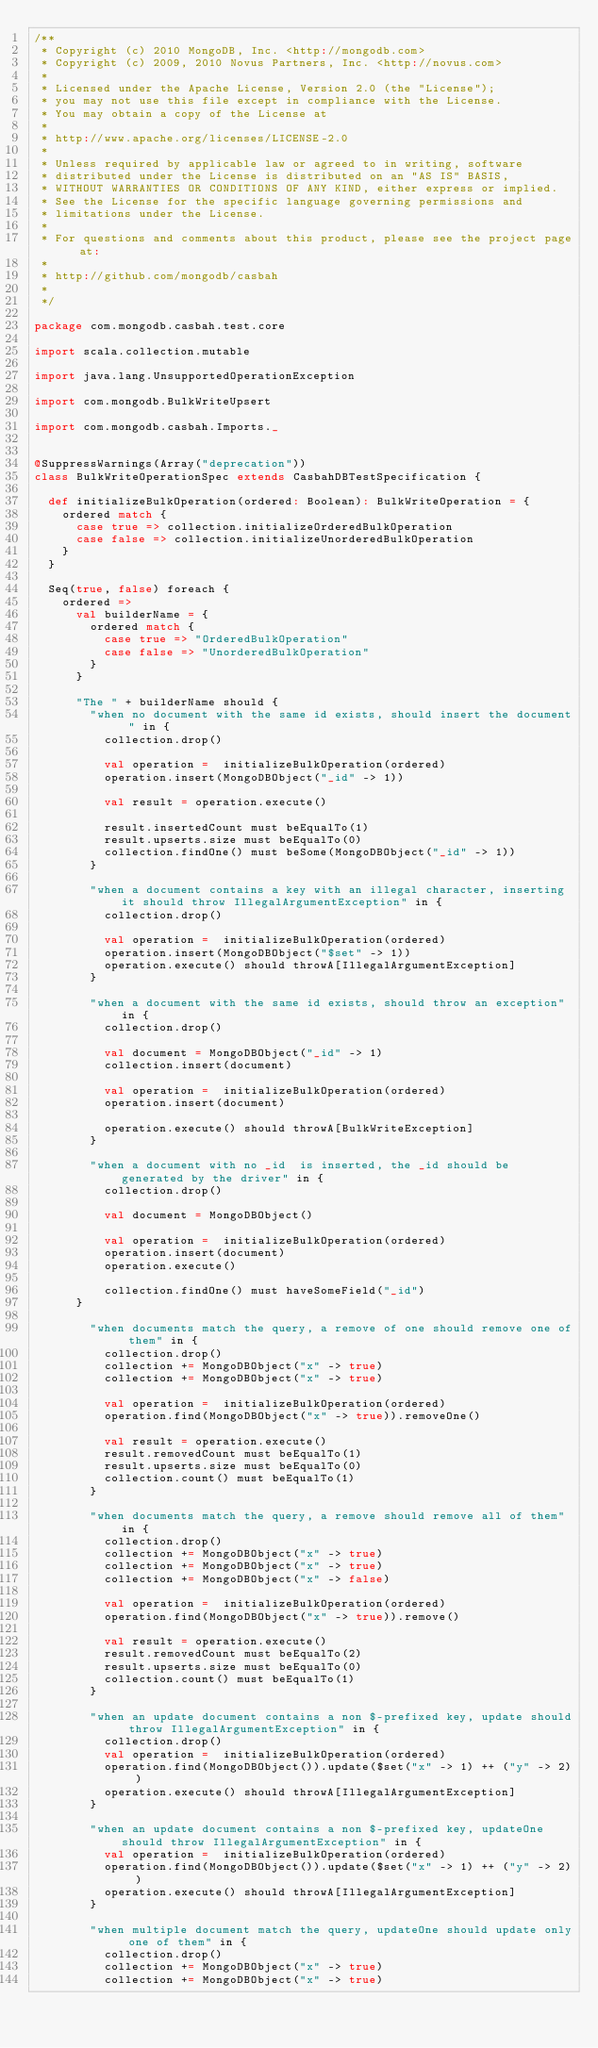<code> <loc_0><loc_0><loc_500><loc_500><_Scala_>/**
 * Copyright (c) 2010 MongoDB, Inc. <http://mongodb.com>
 * Copyright (c) 2009, 2010 Novus Partners, Inc. <http://novus.com>
 *
 * Licensed under the Apache License, Version 2.0 (the "License");
 * you may not use this file except in compliance with the License.
 * You may obtain a copy of the License at
 *
 * http://www.apache.org/licenses/LICENSE-2.0
 *
 * Unless required by applicable law or agreed to in writing, software
 * distributed under the License is distributed on an "AS IS" BASIS,
 * WITHOUT WARRANTIES OR CONDITIONS OF ANY KIND, either express or implied.
 * See the License for the specific language governing permissions and
 * limitations under the License.
 *
 * For questions and comments about this product, please see the project page at:
 *
 * http://github.com/mongodb/casbah
 *
 */

package com.mongodb.casbah.test.core

import scala.collection.mutable

import java.lang.UnsupportedOperationException

import com.mongodb.BulkWriteUpsert

import com.mongodb.casbah.Imports._


@SuppressWarnings(Array("deprecation"))
class BulkWriteOperationSpec extends CasbahDBTestSpecification {

  def initializeBulkOperation(ordered: Boolean): BulkWriteOperation = {
    ordered match {
      case true => collection.initializeOrderedBulkOperation
      case false => collection.initializeUnorderedBulkOperation
    }
  }

  Seq(true, false) foreach {
    ordered =>
      val builderName = {
        ordered match {
          case true => "OrderedBulkOperation"
          case false => "UnorderedBulkOperation"
        }
      }

      "The " + builderName should {
        "when no document with the same id exists, should insert the document " in {
          collection.drop()

          val operation =  initializeBulkOperation(ordered)
          operation.insert(MongoDBObject("_id" -> 1))

          val result = operation.execute()

          result.insertedCount must beEqualTo(1)
          result.upserts.size must beEqualTo(0)
          collection.findOne() must beSome(MongoDBObject("_id" -> 1))
        }

        "when a document contains a key with an illegal character, inserting it should throw IllegalArgumentException" in {
          collection.drop()

          val operation =  initializeBulkOperation(ordered)
          operation.insert(MongoDBObject("$set" -> 1))
          operation.execute() should throwA[IllegalArgumentException]
        }

        "when a document with the same id exists, should throw an exception" in {
          collection.drop()

          val document = MongoDBObject("_id" -> 1)
          collection.insert(document)

          val operation =  initializeBulkOperation(ordered)
          operation.insert(document)

          operation.execute() should throwA[BulkWriteException]
        }

        "when a document with no _id  is inserted, the _id should be generated by the driver" in {
          collection.drop()

          val document = MongoDBObject()

          val operation =  initializeBulkOperation(ordered)
          operation.insert(document)
          operation.execute()

          collection.findOne() must haveSomeField("_id")
      }

        "when documents match the query, a remove of one should remove one of them" in {
          collection.drop()
          collection += MongoDBObject("x" -> true)
          collection += MongoDBObject("x" -> true)

          val operation =  initializeBulkOperation(ordered)
          operation.find(MongoDBObject("x" -> true)).removeOne()

          val result = operation.execute()
          result.removedCount must beEqualTo(1)
          result.upserts.size must beEqualTo(0)
          collection.count() must beEqualTo(1)
        }

        "when documents match the query, a remove should remove all of them" in {
          collection.drop()
          collection += MongoDBObject("x" -> true)
          collection += MongoDBObject("x" -> true)
          collection += MongoDBObject("x" -> false)

          val operation =  initializeBulkOperation(ordered)
          operation.find(MongoDBObject("x" -> true)).remove()

          val result = operation.execute()
          result.removedCount must beEqualTo(2)
          result.upserts.size must beEqualTo(0)
          collection.count() must beEqualTo(1)
        }

        "when an update document contains a non $-prefixed key, update should throw IllegalArgumentException" in {
          collection.drop()
          val operation =  initializeBulkOperation(ordered)
          operation.find(MongoDBObject()).update($set("x" -> 1) ++ ("y" -> 2))
          operation.execute() should throwA[IllegalArgumentException]
        }

        "when an update document contains a non $-prefixed key, updateOne should throw IllegalArgumentException" in {
          val operation =  initializeBulkOperation(ordered)
          operation.find(MongoDBObject()).update($set("x" -> 1) ++ ("y" -> 2))
          operation.execute() should throwA[IllegalArgumentException]
        }

        "when multiple document match the query, updateOne should update only one of them" in {
          collection.drop()
          collection += MongoDBObject("x" -> true)
          collection += MongoDBObject("x" -> true)
</code> 